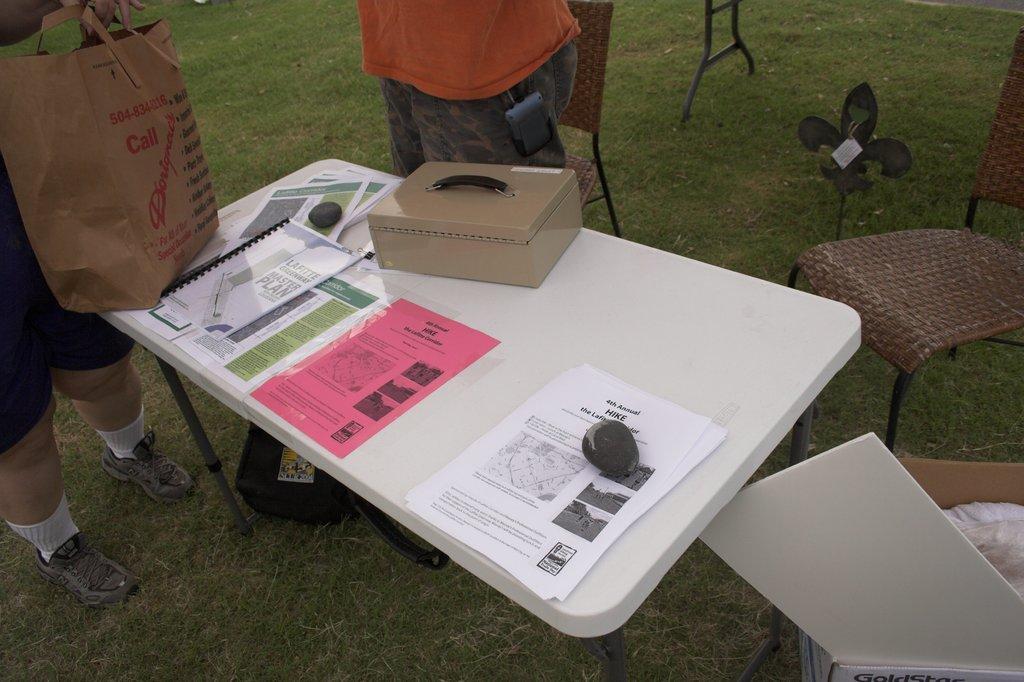Describe this image in one or two sentences. The image consists of table on which there are papers,stones and box. Beside the table there are two person who are standing on the ground. To the right side top corner there is a chair. 